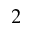<formula> <loc_0><loc_0><loc_500><loc_500>^ { 2 }</formula> 